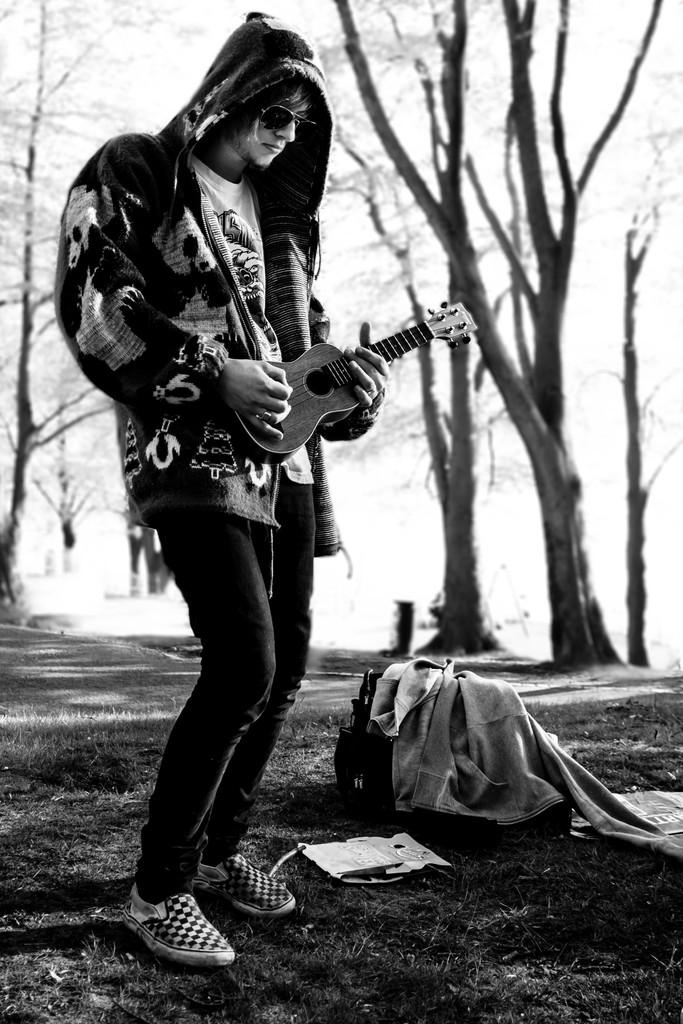What is the color scheme of the image? The image is black and white. Who is present in the image? There is a man in the image. What is the man wearing? The man is wearing a jacket. What is the man doing in the image? The man is playing a guitar. What objects are on the floor in the image? There is a bag and a jacket on the floor in the image. What can be seen in the background of the image? There are bare trees in the background of the image. How many grapes are hanging from the guitar in the image? There are no grapes present in the image, and they are not hanging from the guitar. 